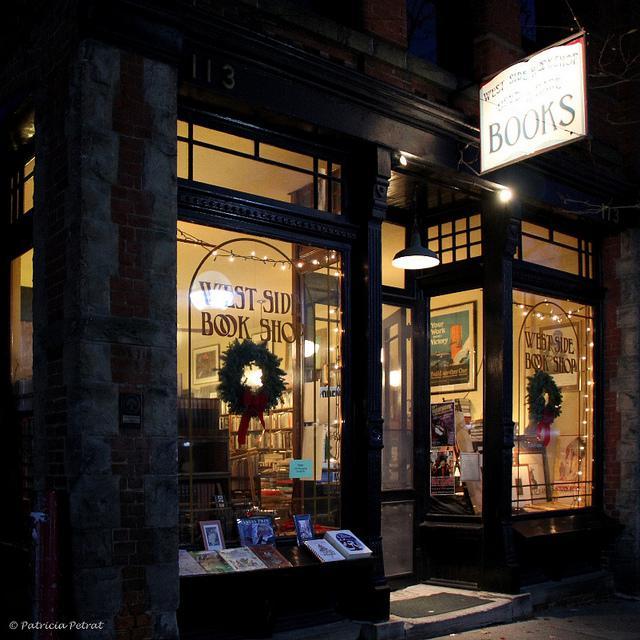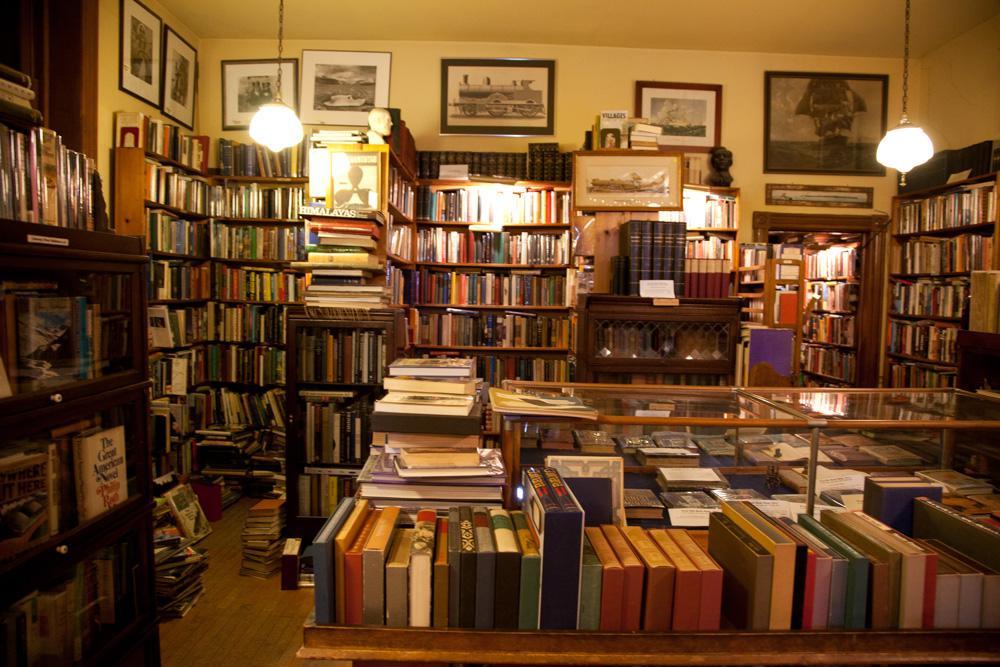The first image is the image on the left, the second image is the image on the right. Assess this claim about the two images: "A bookstore in a brick building is shown in one image with people on the sidewalk outside, with a second image showing outdoor book racks.". Correct or not? Answer yes or no. No. The first image is the image on the left, the second image is the image on the right. Assess this claim about the two images: "A sign hangs outside the door of a brick bookstore in each of the images.". Correct or not? Answer yes or no. No. 